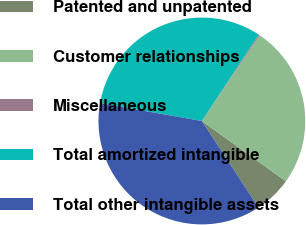<chart> <loc_0><loc_0><loc_500><loc_500><pie_chart><fcel>Patented and unpatented<fcel>Customer relationships<fcel>Miscellaneous<fcel>Total amortized intangible<fcel>Total other intangible assets<nl><fcel>5.87%<fcel>25.46%<fcel>0.18%<fcel>31.5%<fcel>36.99%<nl></chart> 